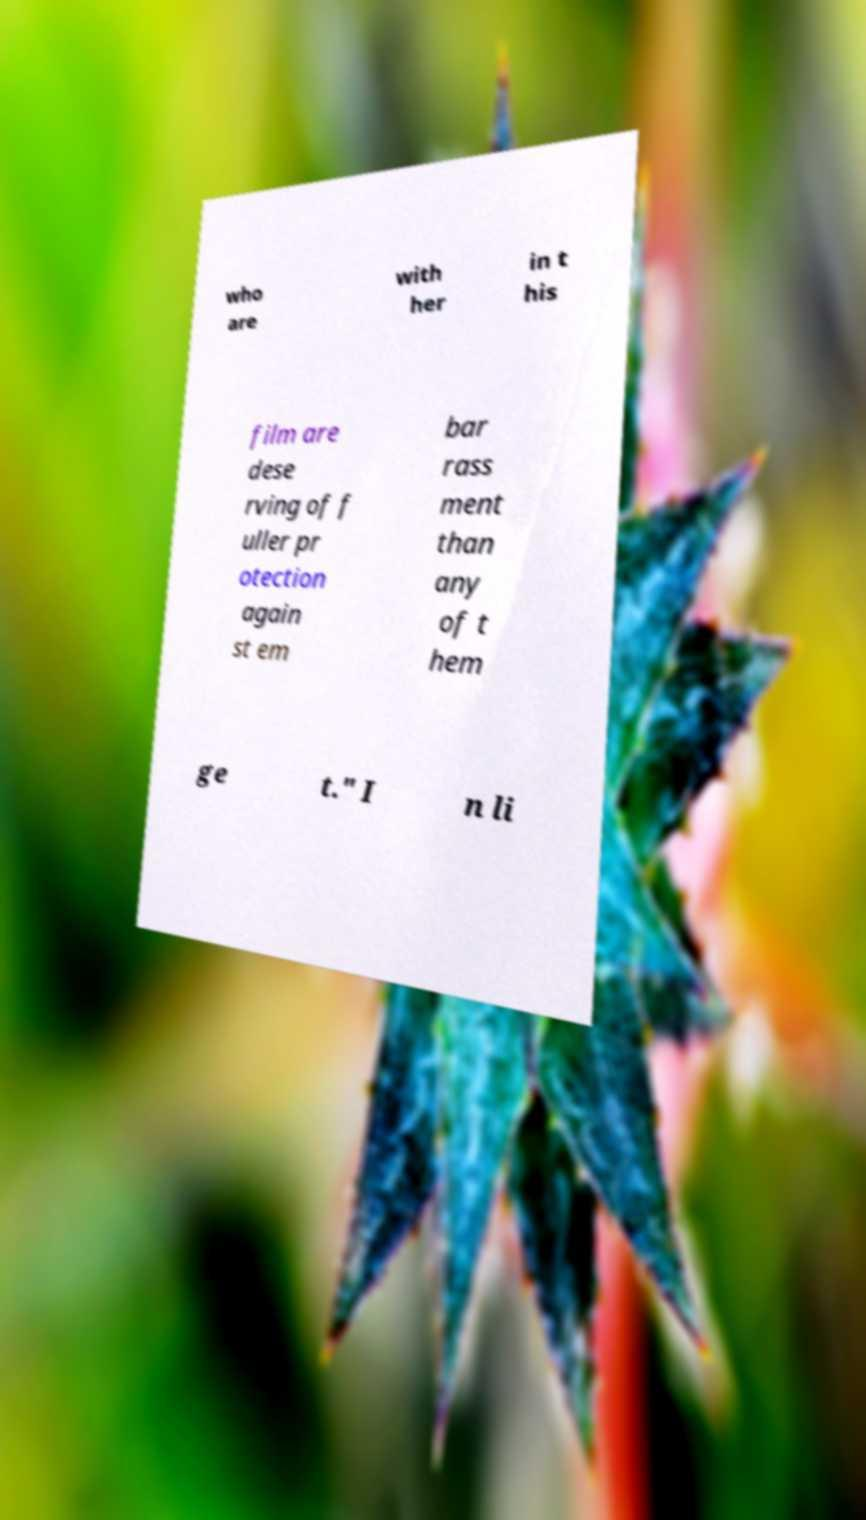Please identify and transcribe the text found in this image. who are with her in t his film are dese rving of f uller pr otection again st em bar rass ment than any of t hem ge t." I n li 